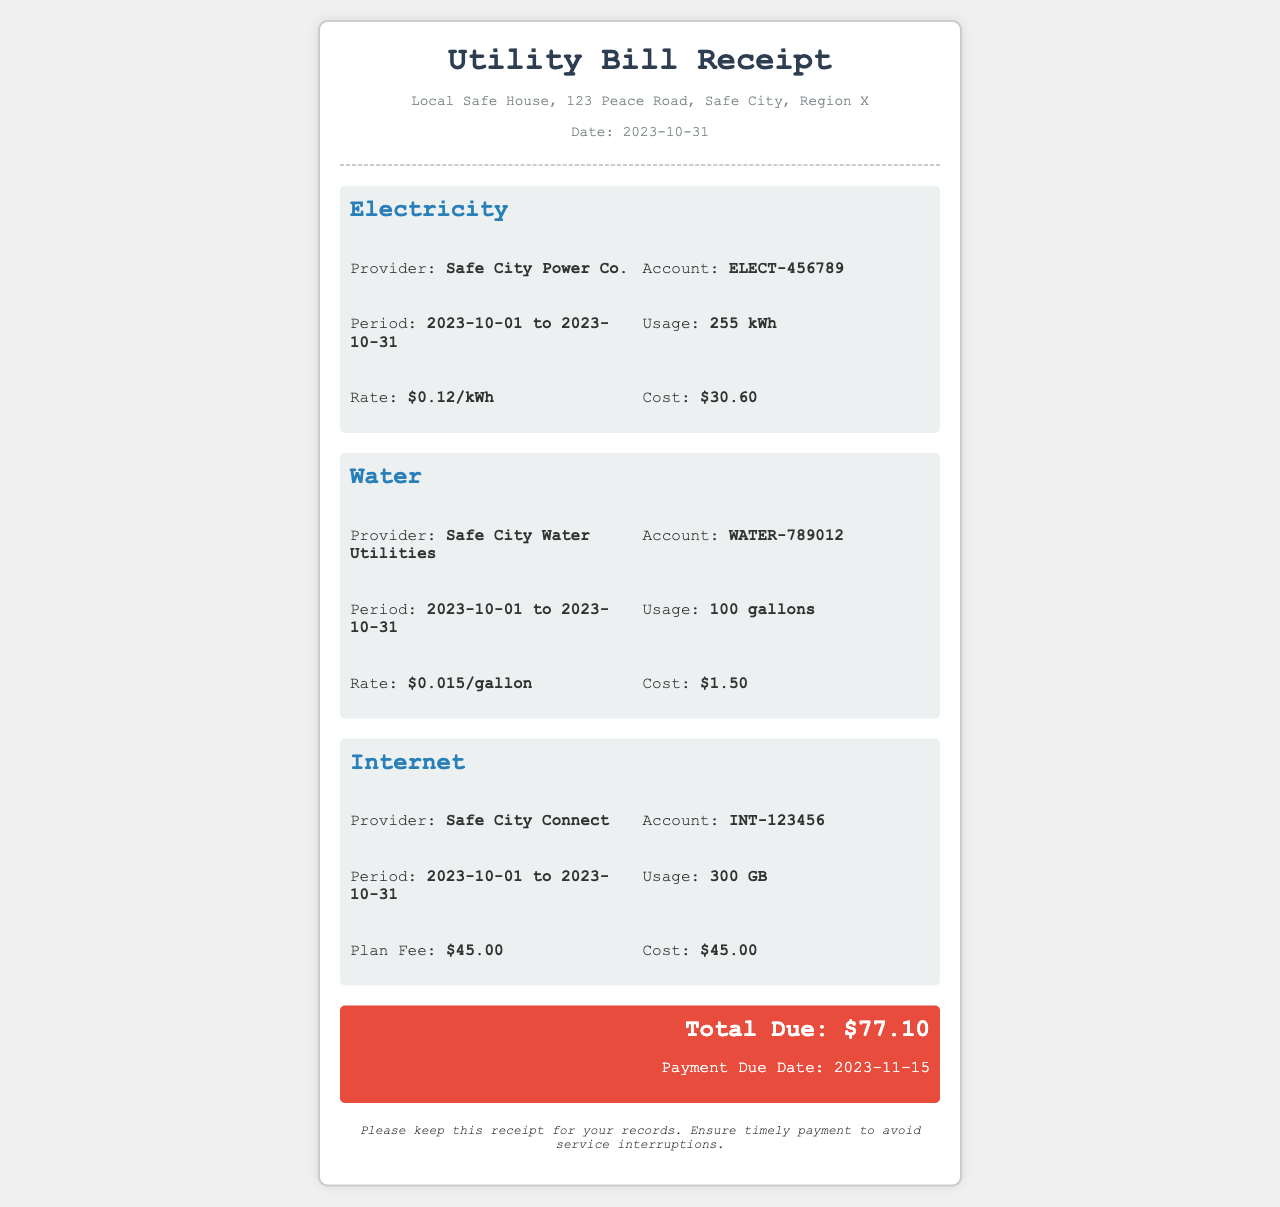What is the date of the receipt? The date of the receipt is mentioned in the document as when the utility bill is issued.
Answer: 2023-10-31 What is the total amount due? The total due is the sum of all utility costs in the receipt, displayed prominently in the summary section.
Answer: $77.10 How much electricity was used? The utility receipt specifies the electricity usage in kilowatt-hours (kWh).
Answer: 255 kWh What is the rate for water usage? The water rate is provided in the water section for each gallon used.
Answer: $0.015/gallon Who is the internet provider? The document includes the name of the service provider for the internet utility.
Answer: Safe City Connect What is the account number for electricity? The account number for the electricity service can be found in the details section presented in the document.
Answer: ELECT-456789 What is the usage period for water? The usage period is indicated for each utility in the receipt, showing when the services were used.
Answer: 2023-10-01 to 2023-10-31 What is the cost of water? The cost is specifically mentioned under the water section and is calculated based on the rate and usage.
Answer: $1.50 When is the payment due date? The due date for the total payment is clearly stated in the summary section of the receipt.
Answer: 2023-11-15 